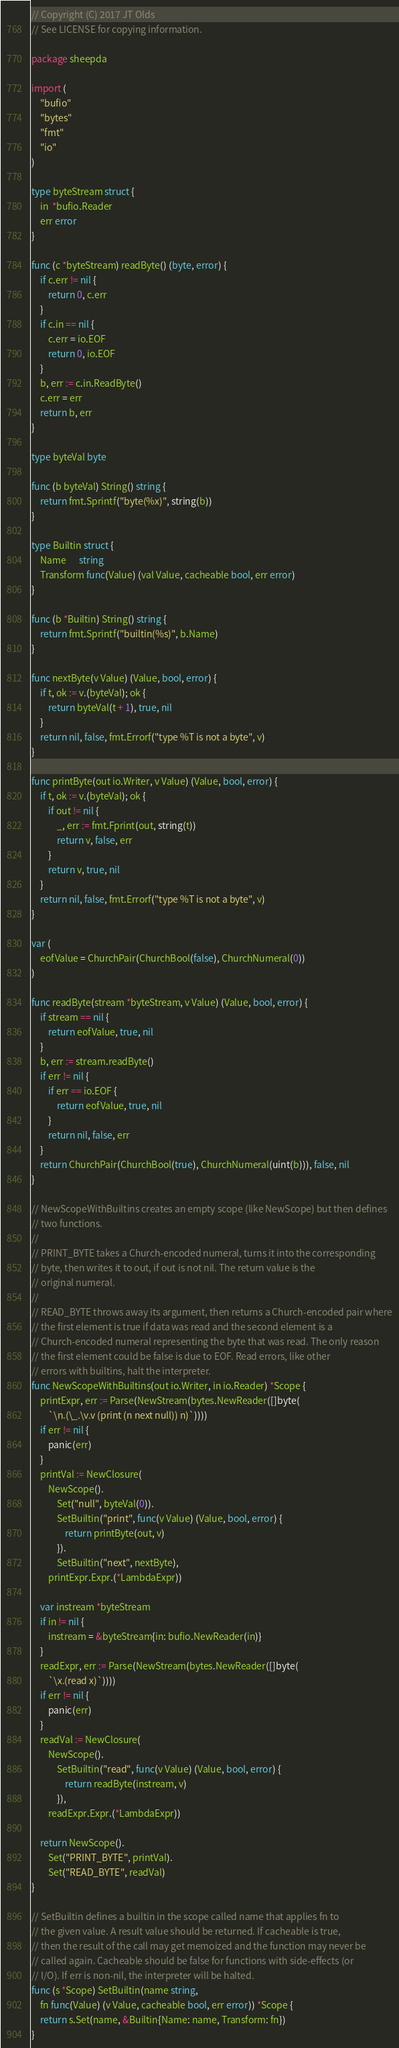Convert code to text. <code><loc_0><loc_0><loc_500><loc_500><_Go_>// Copyright (C) 2017 JT Olds
// See LICENSE for copying information.

package sheepda

import (
	"bufio"
	"bytes"
	"fmt"
	"io"
)

type byteStream struct {
	in  *bufio.Reader
	err error
}

func (c *byteStream) readByte() (byte, error) {
	if c.err != nil {
		return 0, c.err
	}
	if c.in == nil {
		c.err = io.EOF
		return 0, io.EOF
	}
	b, err := c.in.ReadByte()
	c.err = err
	return b, err
}

type byteVal byte

func (b byteVal) String() string {
	return fmt.Sprintf("byte(%x)", string(b))
}

type Builtin struct {
	Name      string
	Transform func(Value) (val Value, cacheable bool, err error)
}

func (b *Builtin) String() string {
	return fmt.Sprintf("builtin(%s)", b.Name)
}

func nextByte(v Value) (Value, bool, error) {
	if t, ok := v.(byteVal); ok {
		return byteVal(t + 1), true, nil
	}
	return nil, false, fmt.Errorf("type %T is not a byte", v)
}

func printByte(out io.Writer, v Value) (Value, bool, error) {
	if t, ok := v.(byteVal); ok {
		if out != nil {
			_, err := fmt.Fprint(out, string(t))
			return v, false, err
		}
		return v, true, nil
	}
	return nil, false, fmt.Errorf("type %T is not a byte", v)
}

var (
	eofValue = ChurchPair(ChurchBool(false), ChurchNumeral(0))
)

func readByte(stream *byteStream, v Value) (Value, bool, error) {
	if stream == nil {
		return eofValue, true, nil
	}
	b, err := stream.readByte()
	if err != nil {
		if err == io.EOF {
			return eofValue, true, nil
		}
		return nil, false, err
	}
	return ChurchPair(ChurchBool(true), ChurchNumeral(uint(b))), false, nil
}

// NewScopeWithBuiltins creates an empty scope (like NewScope) but then defines
// two functions.
//
// PRINT_BYTE takes a Church-encoded numeral, turns it into the corresponding
// byte, then writes it to out, if out is not nil. The return value is the
// original numeral.
//
// READ_BYTE throws away its argument, then returns a Church-encoded pair where
// the first element is true if data was read and the second element is a
// Church-encoded numeral representing the byte that was read. The only reason
// the first element could be false is due to EOF. Read errors, like other
// errors with builtins, halt the interpreter.
func NewScopeWithBuiltins(out io.Writer, in io.Reader) *Scope {
	printExpr, err := Parse(NewStream(bytes.NewReader([]byte(
		`\n.(\_.\v.v (print (n next null)) n)`))))
	if err != nil {
		panic(err)
	}
	printVal := NewClosure(
		NewScope().
			Set("null", byteVal(0)).
			SetBuiltin("print", func(v Value) (Value, bool, error) {
				return printByte(out, v)
			}).
			SetBuiltin("next", nextByte),
		printExpr.Expr.(*LambdaExpr))

	var instream *byteStream
	if in != nil {
		instream = &byteStream{in: bufio.NewReader(in)}
	}
	readExpr, err := Parse(NewStream(bytes.NewReader([]byte(
		`\x.(read x)`))))
	if err != nil {
		panic(err)
	}
	readVal := NewClosure(
		NewScope().
			SetBuiltin("read", func(v Value) (Value, bool, error) {
				return readByte(instream, v)
			}),
		readExpr.Expr.(*LambdaExpr))

	return NewScope().
		Set("PRINT_BYTE", printVal).
		Set("READ_BYTE", readVal)
}

// SetBuiltin defines a builtin in the scope called name that applies fn to
// the given value. A result value should be returned. If cacheable is true,
// then the result of the call may get memoized and the function may never be
// called again. Cacheable should be false for functions with side-effects (or
// I/O). If err is non-nil, the interpreter will be halted.
func (s *Scope) SetBuiltin(name string,
	fn func(Value) (v Value, cacheable bool, err error)) *Scope {
	return s.Set(name, &Builtin{Name: name, Transform: fn})
}
</code> 